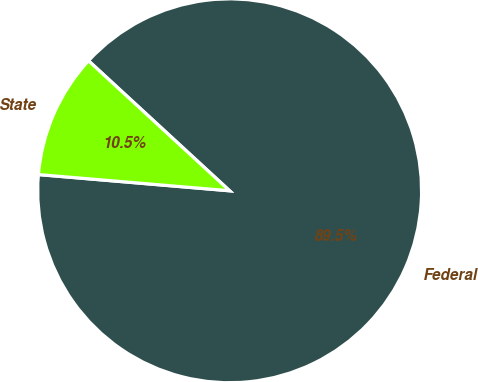Convert chart. <chart><loc_0><loc_0><loc_500><loc_500><pie_chart><fcel>Federal<fcel>State<nl><fcel>89.5%<fcel>10.5%<nl></chart> 